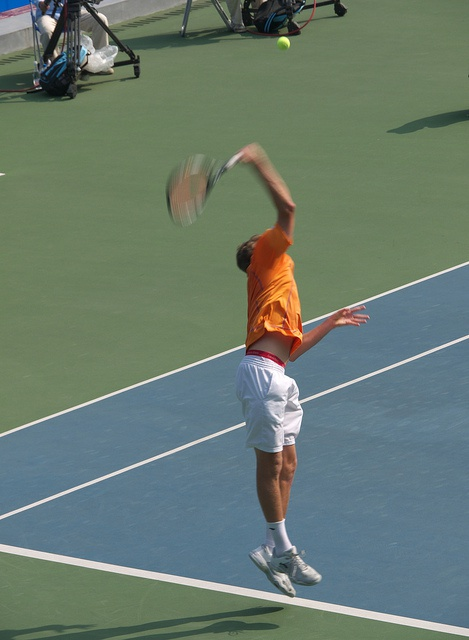Describe the objects in this image and their specific colors. I can see people in blue, gray, maroon, and lightgray tones, tennis racket in blue and gray tones, people in blue, black, gray, darkgray, and lightgray tones, backpack in blue, black, gray, and darkblue tones, and sports ball in blue, khaki, olive, and green tones in this image. 